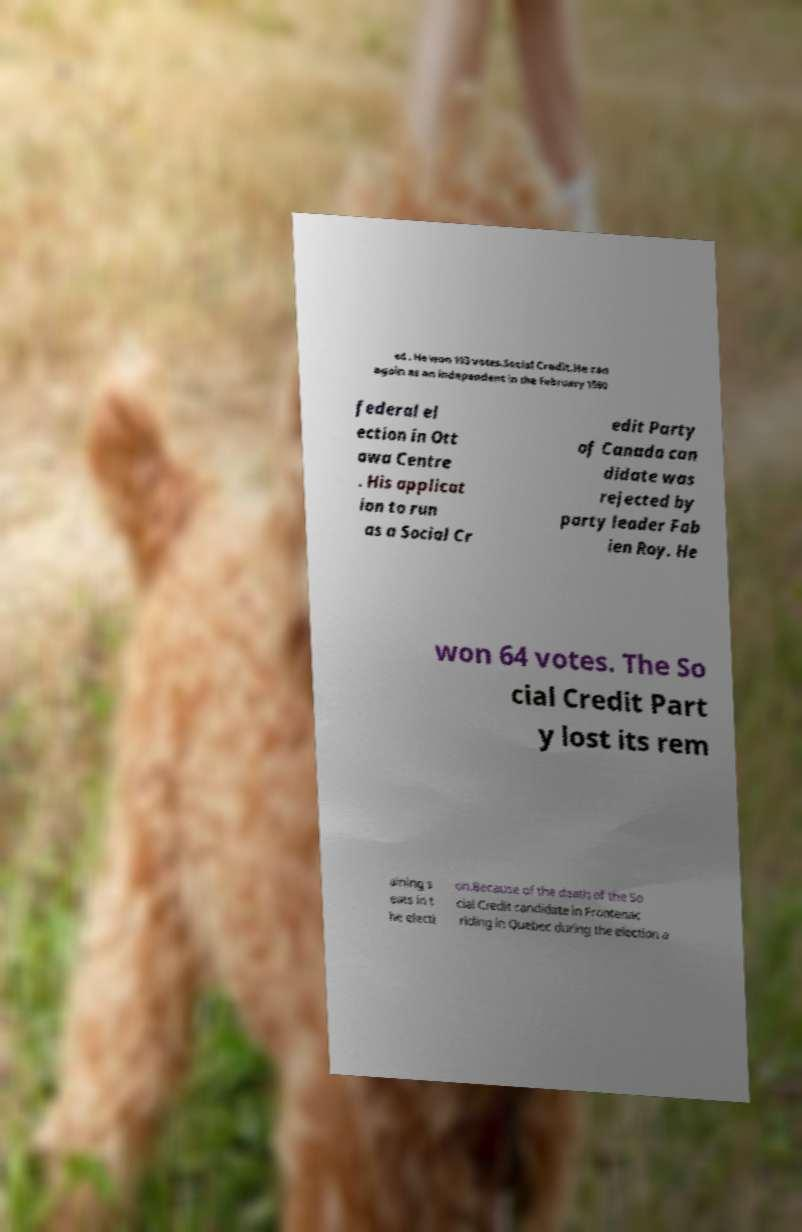Could you assist in decoding the text presented in this image and type it out clearly? ed . He won 193 votes.Social Credit.He ran again as an independent in the February 1980 federal el ection in Ott awa Centre . His applicat ion to run as a Social Cr edit Party of Canada can didate was rejected by party leader Fab ien Roy. He won 64 votes. The So cial Credit Part y lost its rem aining s eats in t he electi on.Because of the death of the So cial Credit candidate in Frontenac riding in Quebec during the election a 